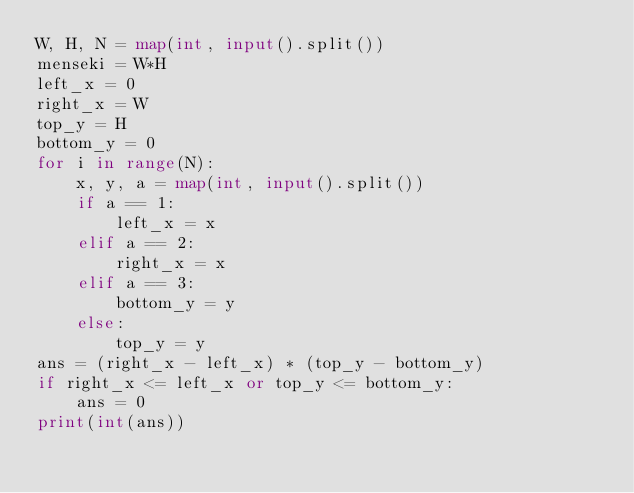<code> <loc_0><loc_0><loc_500><loc_500><_Python_>W, H, N = map(int, input().split())
menseki = W*H
left_x = 0
right_x = W
top_y = H
bottom_y = 0
for i in range(N):
    x, y, a = map(int, input().split())
    if a == 1:
        left_x = x
    elif a == 2:
        right_x = x
    elif a == 3:
        bottom_y = y
    else:
        top_y = y
ans = (right_x - left_x) * (top_y - bottom_y)
if right_x <= left_x or top_y <= bottom_y:
    ans = 0
print(int(ans))    
</code> 